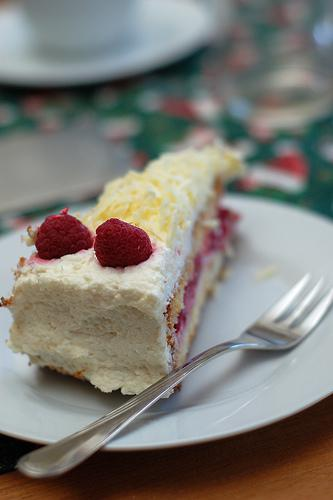Question: when would a person probably eat this food item?
Choices:
A. Snack time.
B. Whenever they wanted.
C. In evening.
D. After main meal.
Answer with the letter. Answer: D Question: who may have taken this photo?
Choices:
A. Cook.
B. Food photographer.
C. Father.
D. Young woman.
Answer with the letter. Answer: B Question: where is this food item located?
Choices:
A. In refrigerator.
B. In oven.
C. On plate.
D. On table.
Answer with the letter. Answer: C Question: why is the fork to the right of food item?
Choices:
A. Where it was placed.
B. To use.
C. To eat it with.
D. To serve meat with.
Answer with the letter. Answer: C Question: how other than fork could a person eat this food?
Choices:
A. Chop sticks.
B. Hands.
C. Spoon.
D. Toothpick.
Answer with the letter. Answer: C Question: what are the berries on top of cake probably called?
Choices:
A. Raspberries.
B. Strawberries.
C. Blueberries.
D. Blackberries.
Answer with the letter. Answer: B Question: what color are the strawberries?
Choices:
A. Green.
B. Pink.
C. White.
D. Red.
Answer with the letter. Answer: D 